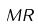Convert formula to latex. <formula><loc_0><loc_0><loc_500><loc_500>M R</formula> 